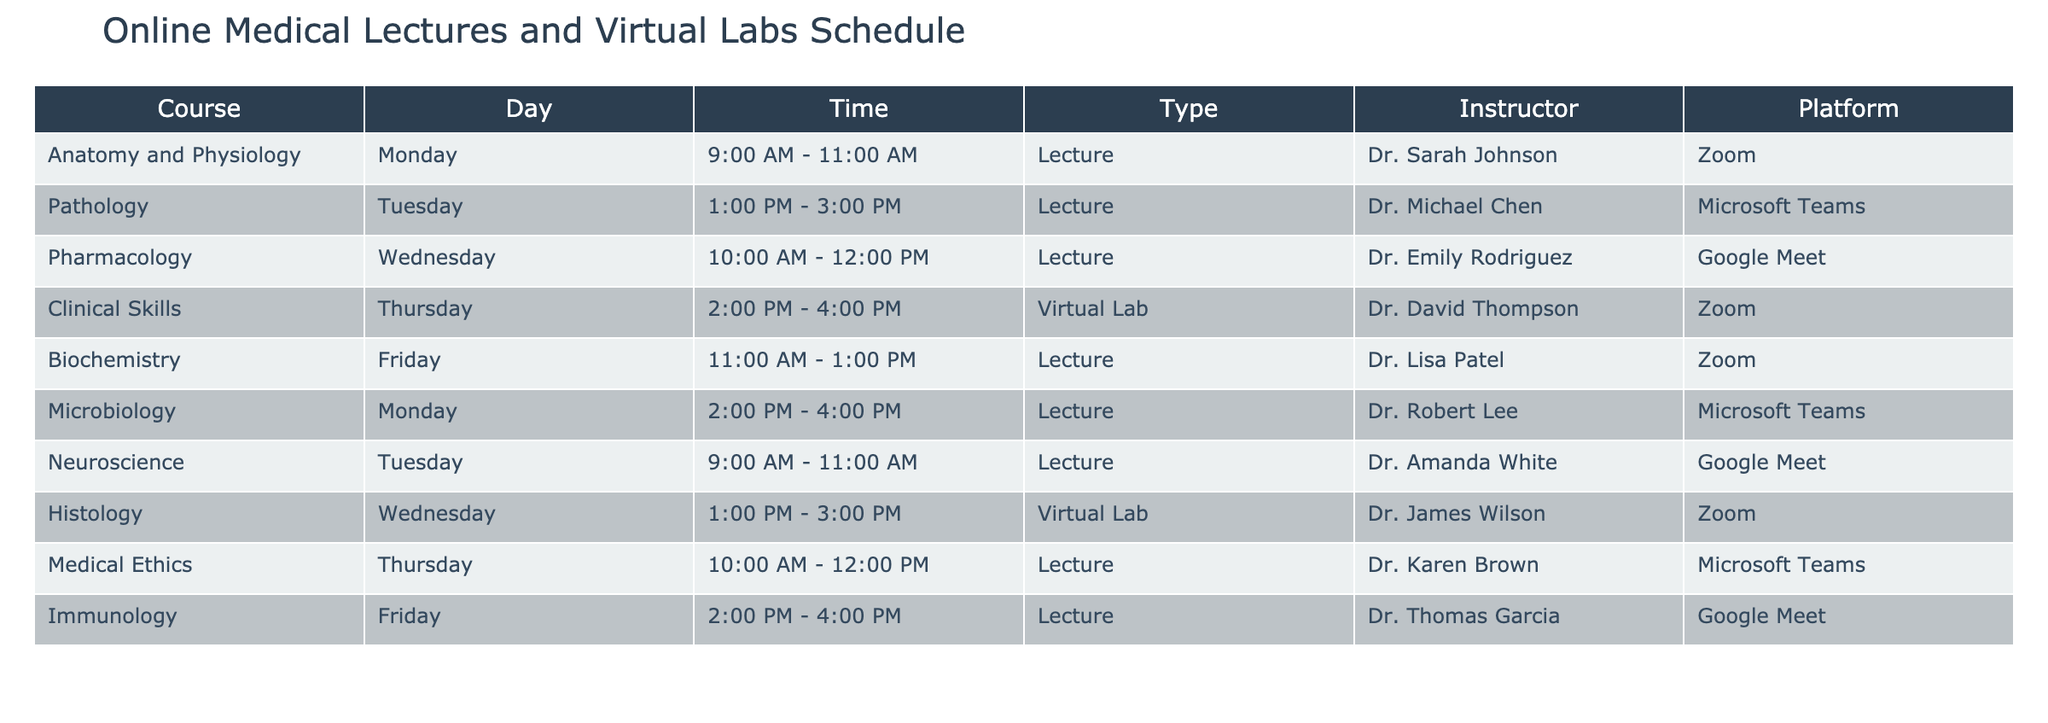What day is the lecture for Pharmacology scheduled? The table indicates that the lecture for Pharmacology takes place on Wednesday.
Answer: Wednesday Which instructor teaches Clinical Skills? According to the table, Clinical Skills is taught by Dr. David Thompson.
Answer: Dr. David Thompson Is there a lecture scheduled on Tuesday? Yes, the table lists two lectures on Tuesday: Pathology and Neuroscience.
Answer: Yes How many total subjects have lectures scheduled on Monday? The table shows two subjects with lectures on Monday: Anatomy and Physiology and Microbiology. Therefore, the total is 2.
Answer: 2 Which platform is used for the Biochemistry lecture? The table states that the Biochemistry lecture is conducted on Zoom.
Answer: Zoom What is the time interval between the start of Anatomy and Physiology and the end of Immunology lectures on Fridays? The Anatomy and Physiology lecture starts at 9:00 AM and ends at 11:00 AM, while Immunology starts at 2:00 PM and ends at 4:00 PM. The interval is from 11:00 AM to 2:00 PM, which totals 3 hours.
Answer: 3 hours Which day has a virtual lab scheduled? The table indicates that there is one virtual lab scheduled on Thursday for the Clinical Skills course.
Answer: Thursday How many instructors teach on Microsoft Teams? The table shows Pathology, Medical Ethics, and Microbiology being taught by three different instructors on Microsoft Teams. Thus, the total is 3.
Answer: 3 On which platform does the Histology virtual lab occur? The table indicates that the Histology virtual lab is conducted on Zoom.
Answer: Zoom What is the total number of different courses taught by Dr. Emily Rodriguez? The table shows that Dr. Emily Rodriguez teaches one course, Pharmacology.
Answer: 1 